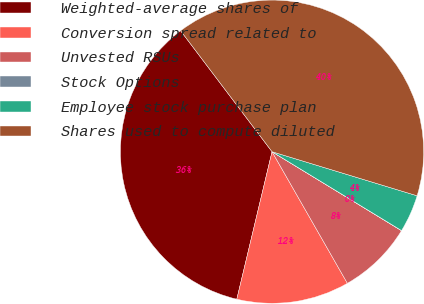Convert chart. <chart><loc_0><loc_0><loc_500><loc_500><pie_chart><fcel>Weighted-average shares of<fcel>Conversion spread related to<fcel>Unvested RSUs<fcel>Stock Options<fcel>Employee stock purchase plan<fcel>Shares used to compute diluted<nl><fcel>35.97%<fcel>12.01%<fcel>8.01%<fcel>0.01%<fcel>4.01%<fcel>40.0%<nl></chart> 